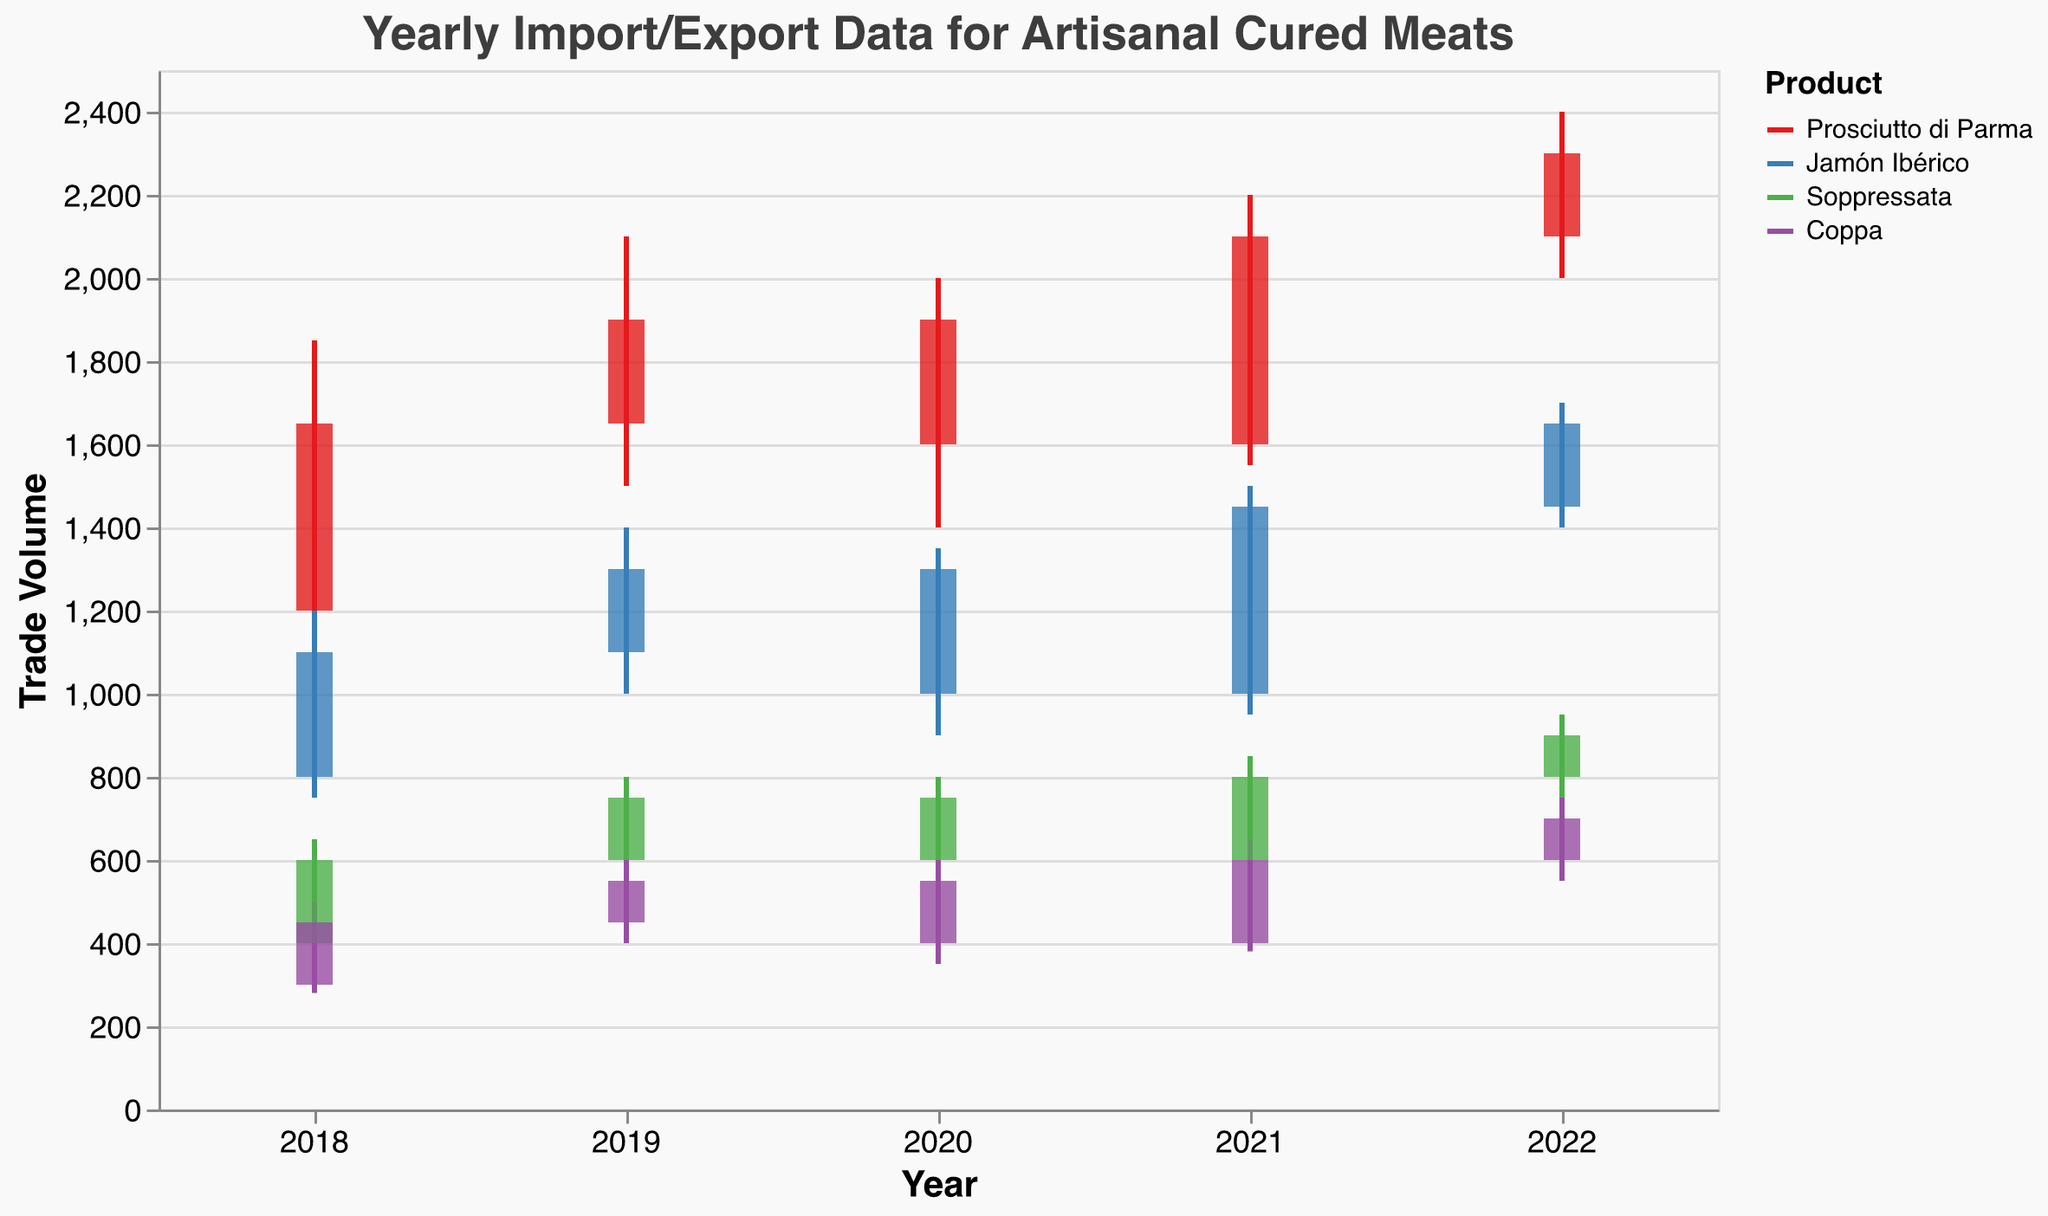What is the title of the chart? The title of the chart is displayed at the top and reads "Yearly Import/Export Data for Artisanal Cured Meats".
Answer: Yearly Import/Export Data for Artisanal Cured Meats What are the four types of products displayed in the chart? The chart uses color coding to differentiate between four products: "Prosciutto di Parma", "Jamón Ibérico", "Soppressata", and "Coppa".
Answer: Prosciutto di Parma, Jamón Ibérico, Soppressata, Coppa Which product had the highest trade volume recorded in any year? Observe the vertical bars and rules that indicate the highest trade volume for each product. "Prosciutto di Parma" had the highest recorded trade volume of 2400 in the year 2022.
Answer: Prosciutto di Parma In which year did "Jamón Ibérico" open at the lowest trade volume? Look at the "Opening" trade volume for "Jamón Ibérico" across all years. It opened at its lowest trade volume of 800 in 2018.
Answer: 2018 Compare the opening and closing trade volumes for "Coppa" in 2018. What is the difference? For the year 2018, observe the "Opening" and "Closing" volumes for "Coppa". They are 300 and 450, respectively. The difference is 450 - 300 = 150.
Answer: 150 Which product showed the greatest improvement in closing trade volume from 2021 to 2022? Compare the closing trade volumes for each product in 2021 and 2022: 
- "Prosciutto di Parma": 2100 to 2300 (increase of 200)
- "Jamón Ibérico": 1450 to 1650 (increase of 200)
- "Soppressata": 800 to 900 (increase of 100)
- "Coppa": 600 to 700 (increase of 100)
Both "Prosciutto di Parma" and "Jamón Ibérico" showed the greatest increase of 200.
Answer: Prosciutto di Parma, Jamón Ibérico What is the range of trade volumes for "Soppressata" in 2020? The range of trade volumes is the difference between the highest and lowest values. For "Soppressata" in 2020, the volumes were 800 and 500 respectively. The range is 800 - 500 = 300.
Answer: 300 Which year had the highest closing trade volume for "Prosciutto di Parma"? Examine the closing trade volumes for "Prosciutto di Parma" for each year and identify the highest. The highest closing trade volume of 2300 occurred in 2022.
Answer: 2022 What is the average highest trade volume for "Coppa" over the four years? To find the average highest volume, sum the highest volumes for each year (500, 600, 600, 750) and divide by the number of years:
(500 + 600 + 600 + 750) / 4 = 2450 / 4 = 612.5.
Answer: 612.5 Between 2018 and 2019, did "Soppressata" experience an increase or decrease in its closing trade volume? By how much? Compare the closing trade volumes for "Soppressata" between 2018 (600) and 2019 (750). The change is 750 - 600 = 150, indicating an increase.
Answer: Increase by 150 